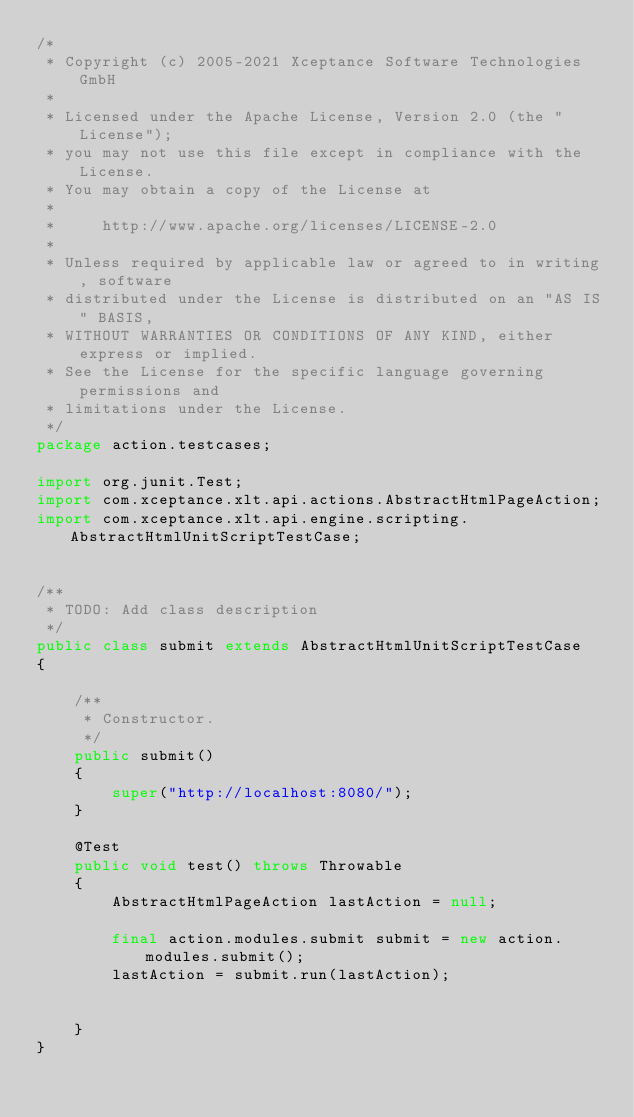<code> <loc_0><loc_0><loc_500><loc_500><_Java_>/*
 * Copyright (c) 2005-2021 Xceptance Software Technologies GmbH
 *
 * Licensed under the Apache License, Version 2.0 (the "License");
 * you may not use this file except in compliance with the License.
 * You may obtain a copy of the License at
 *
 *     http://www.apache.org/licenses/LICENSE-2.0
 *
 * Unless required by applicable law or agreed to in writing, software
 * distributed under the License is distributed on an "AS IS" BASIS,
 * WITHOUT WARRANTIES OR CONDITIONS OF ANY KIND, either express or implied.
 * See the License for the specific language governing permissions and
 * limitations under the License.
 */
package action.testcases;

import org.junit.Test;
import com.xceptance.xlt.api.actions.AbstractHtmlPageAction;
import com.xceptance.xlt.api.engine.scripting.AbstractHtmlUnitScriptTestCase;


/**
 * TODO: Add class description
 */
public class submit extends AbstractHtmlUnitScriptTestCase
{

    /**
     * Constructor.
     */
    public submit()
    {
        super("http://localhost:8080/");
    }

    @Test
    public void test() throws Throwable
    {
        AbstractHtmlPageAction lastAction = null;

        final action.modules.submit submit = new action.modules.submit();
        lastAction = submit.run(lastAction);


    }
}</code> 